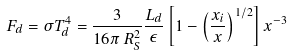Convert formula to latex. <formula><loc_0><loc_0><loc_500><loc_500>F _ { d } = \sigma T _ { d } ^ { 4 } = \frac { 3 } { 1 6 \pi \, R _ { S } ^ { 2 } } \frac { L _ { d } } { \epsilon } \left [ 1 - \left ( \frac { x _ { i } } { x } \right ) ^ { 1 / 2 } \right ] x ^ { - 3 }</formula> 